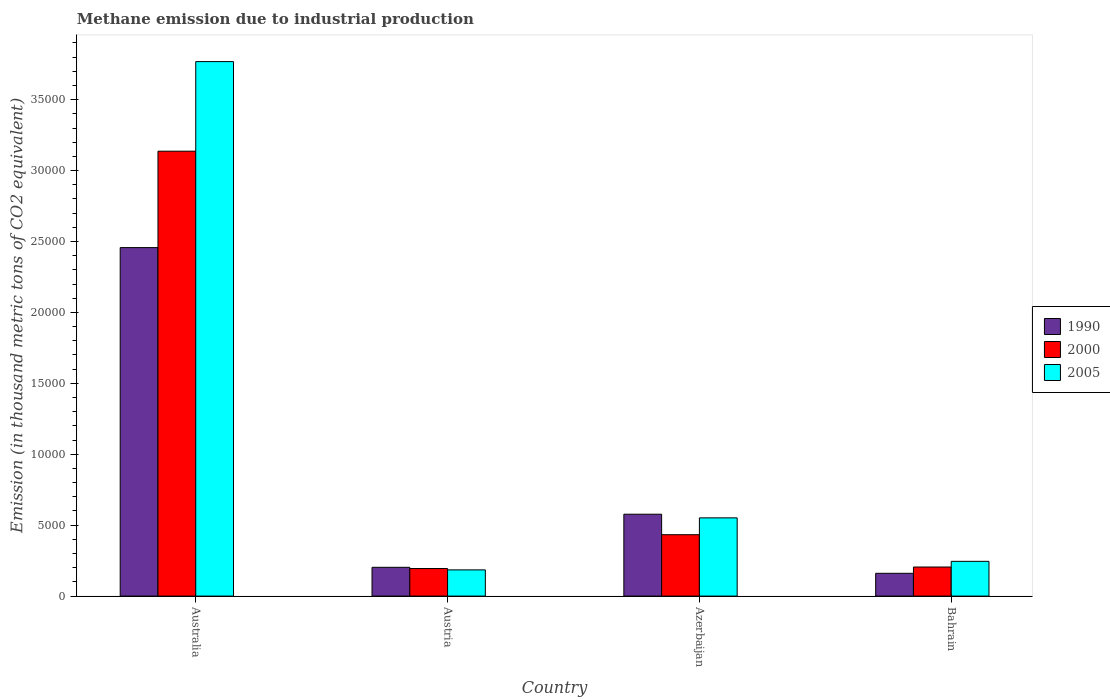How many groups of bars are there?
Your answer should be very brief. 4. How many bars are there on the 2nd tick from the left?
Offer a terse response. 3. How many bars are there on the 3rd tick from the right?
Make the answer very short. 3. What is the amount of methane emitted in 1990 in Austria?
Your response must be concise. 2030.6. Across all countries, what is the maximum amount of methane emitted in 1990?
Offer a very short reply. 2.46e+04. Across all countries, what is the minimum amount of methane emitted in 1990?
Offer a very short reply. 1607.3. What is the total amount of methane emitted in 2005 in the graph?
Your answer should be compact. 4.75e+04. What is the difference between the amount of methane emitted in 2000 in Australia and that in Azerbaijan?
Keep it short and to the point. 2.70e+04. What is the difference between the amount of methane emitted in 2005 in Bahrain and the amount of methane emitted in 2000 in Azerbaijan?
Provide a succinct answer. -1877.2. What is the average amount of methane emitted in 1990 per country?
Ensure brevity in your answer.  8495.27. What is the difference between the amount of methane emitted of/in 2000 and amount of methane emitted of/in 1990 in Australia?
Your answer should be very brief. 6797.8. What is the ratio of the amount of methane emitted in 2005 in Azerbaijan to that in Bahrain?
Your answer should be compact. 2.25. Is the amount of methane emitted in 1990 in Australia less than that in Azerbaijan?
Your response must be concise. No. What is the difference between the highest and the second highest amount of methane emitted in 1990?
Provide a succinct answer. 1.88e+04. What is the difference between the highest and the lowest amount of methane emitted in 2000?
Offer a terse response. 2.94e+04. Is the sum of the amount of methane emitted in 2005 in Austria and Bahrain greater than the maximum amount of methane emitted in 1990 across all countries?
Your response must be concise. No. What does the 2nd bar from the left in Bahrain represents?
Provide a short and direct response. 2000. Are all the bars in the graph horizontal?
Make the answer very short. No. What is the difference between two consecutive major ticks on the Y-axis?
Ensure brevity in your answer.  5000. Does the graph contain grids?
Provide a succinct answer. No. Where does the legend appear in the graph?
Your response must be concise. Center right. How many legend labels are there?
Ensure brevity in your answer.  3. How are the legend labels stacked?
Your response must be concise. Vertical. What is the title of the graph?
Ensure brevity in your answer.  Methane emission due to industrial production. Does "1985" appear as one of the legend labels in the graph?
Your response must be concise. No. What is the label or title of the X-axis?
Offer a terse response. Country. What is the label or title of the Y-axis?
Your response must be concise. Emission (in thousand metric tons of CO2 equivalent). What is the Emission (in thousand metric tons of CO2 equivalent) of 1990 in Australia?
Your answer should be very brief. 2.46e+04. What is the Emission (in thousand metric tons of CO2 equivalent) in 2000 in Australia?
Provide a succinct answer. 3.14e+04. What is the Emission (in thousand metric tons of CO2 equivalent) in 2005 in Australia?
Offer a terse response. 3.77e+04. What is the Emission (in thousand metric tons of CO2 equivalent) of 1990 in Austria?
Offer a terse response. 2030.6. What is the Emission (in thousand metric tons of CO2 equivalent) in 2000 in Austria?
Your response must be concise. 1944.7. What is the Emission (in thousand metric tons of CO2 equivalent) of 2005 in Austria?
Your answer should be compact. 1848.3. What is the Emission (in thousand metric tons of CO2 equivalent) in 1990 in Azerbaijan?
Keep it short and to the point. 5773. What is the Emission (in thousand metric tons of CO2 equivalent) of 2000 in Azerbaijan?
Provide a succinct answer. 4327.8. What is the Emission (in thousand metric tons of CO2 equivalent) in 2005 in Azerbaijan?
Make the answer very short. 5515.2. What is the Emission (in thousand metric tons of CO2 equivalent) in 1990 in Bahrain?
Provide a short and direct response. 1607.3. What is the Emission (in thousand metric tons of CO2 equivalent) of 2000 in Bahrain?
Ensure brevity in your answer.  2050.3. What is the Emission (in thousand metric tons of CO2 equivalent) in 2005 in Bahrain?
Provide a short and direct response. 2450.6. Across all countries, what is the maximum Emission (in thousand metric tons of CO2 equivalent) in 1990?
Your answer should be compact. 2.46e+04. Across all countries, what is the maximum Emission (in thousand metric tons of CO2 equivalent) in 2000?
Make the answer very short. 3.14e+04. Across all countries, what is the maximum Emission (in thousand metric tons of CO2 equivalent) in 2005?
Give a very brief answer. 3.77e+04. Across all countries, what is the minimum Emission (in thousand metric tons of CO2 equivalent) of 1990?
Offer a terse response. 1607.3. Across all countries, what is the minimum Emission (in thousand metric tons of CO2 equivalent) of 2000?
Ensure brevity in your answer.  1944.7. Across all countries, what is the minimum Emission (in thousand metric tons of CO2 equivalent) of 2005?
Offer a terse response. 1848.3. What is the total Emission (in thousand metric tons of CO2 equivalent) in 1990 in the graph?
Your answer should be compact. 3.40e+04. What is the total Emission (in thousand metric tons of CO2 equivalent) in 2000 in the graph?
Provide a short and direct response. 3.97e+04. What is the total Emission (in thousand metric tons of CO2 equivalent) of 2005 in the graph?
Ensure brevity in your answer.  4.75e+04. What is the difference between the Emission (in thousand metric tons of CO2 equivalent) in 1990 in Australia and that in Austria?
Ensure brevity in your answer.  2.25e+04. What is the difference between the Emission (in thousand metric tons of CO2 equivalent) of 2000 in Australia and that in Austria?
Your answer should be compact. 2.94e+04. What is the difference between the Emission (in thousand metric tons of CO2 equivalent) of 2005 in Australia and that in Austria?
Give a very brief answer. 3.58e+04. What is the difference between the Emission (in thousand metric tons of CO2 equivalent) in 1990 in Australia and that in Azerbaijan?
Keep it short and to the point. 1.88e+04. What is the difference between the Emission (in thousand metric tons of CO2 equivalent) in 2000 in Australia and that in Azerbaijan?
Give a very brief answer. 2.70e+04. What is the difference between the Emission (in thousand metric tons of CO2 equivalent) of 2005 in Australia and that in Azerbaijan?
Give a very brief answer. 3.22e+04. What is the difference between the Emission (in thousand metric tons of CO2 equivalent) in 1990 in Australia and that in Bahrain?
Provide a short and direct response. 2.30e+04. What is the difference between the Emission (in thousand metric tons of CO2 equivalent) of 2000 in Australia and that in Bahrain?
Your answer should be compact. 2.93e+04. What is the difference between the Emission (in thousand metric tons of CO2 equivalent) of 2005 in Australia and that in Bahrain?
Make the answer very short. 3.52e+04. What is the difference between the Emission (in thousand metric tons of CO2 equivalent) of 1990 in Austria and that in Azerbaijan?
Your answer should be compact. -3742.4. What is the difference between the Emission (in thousand metric tons of CO2 equivalent) in 2000 in Austria and that in Azerbaijan?
Provide a short and direct response. -2383.1. What is the difference between the Emission (in thousand metric tons of CO2 equivalent) of 2005 in Austria and that in Azerbaijan?
Your answer should be compact. -3666.9. What is the difference between the Emission (in thousand metric tons of CO2 equivalent) in 1990 in Austria and that in Bahrain?
Offer a very short reply. 423.3. What is the difference between the Emission (in thousand metric tons of CO2 equivalent) of 2000 in Austria and that in Bahrain?
Make the answer very short. -105.6. What is the difference between the Emission (in thousand metric tons of CO2 equivalent) in 2005 in Austria and that in Bahrain?
Ensure brevity in your answer.  -602.3. What is the difference between the Emission (in thousand metric tons of CO2 equivalent) of 1990 in Azerbaijan and that in Bahrain?
Your answer should be very brief. 4165.7. What is the difference between the Emission (in thousand metric tons of CO2 equivalent) in 2000 in Azerbaijan and that in Bahrain?
Provide a short and direct response. 2277.5. What is the difference between the Emission (in thousand metric tons of CO2 equivalent) of 2005 in Azerbaijan and that in Bahrain?
Make the answer very short. 3064.6. What is the difference between the Emission (in thousand metric tons of CO2 equivalent) of 1990 in Australia and the Emission (in thousand metric tons of CO2 equivalent) of 2000 in Austria?
Offer a terse response. 2.26e+04. What is the difference between the Emission (in thousand metric tons of CO2 equivalent) of 1990 in Australia and the Emission (in thousand metric tons of CO2 equivalent) of 2005 in Austria?
Provide a succinct answer. 2.27e+04. What is the difference between the Emission (in thousand metric tons of CO2 equivalent) of 2000 in Australia and the Emission (in thousand metric tons of CO2 equivalent) of 2005 in Austria?
Your answer should be very brief. 2.95e+04. What is the difference between the Emission (in thousand metric tons of CO2 equivalent) of 1990 in Australia and the Emission (in thousand metric tons of CO2 equivalent) of 2000 in Azerbaijan?
Your answer should be compact. 2.02e+04. What is the difference between the Emission (in thousand metric tons of CO2 equivalent) in 1990 in Australia and the Emission (in thousand metric tons of CO2 equivalent) in 2005 in Azerbaijan?
Your answer should be very brief. 1.91e+04. What is the difference between the Emission (in thousand metric tons of CO2 equivalent) in 2000 in Australia and the Emission (in thousand metric tons of CO2 equivalent) in 2005 in Azerbaijan?
Make the answer very short. 2.59e+04. What is the difference between the Emission (in thousand metric tons of CO2 equivalent) of 1990 in Australia and the Emission (in thousand metric tons of CO2 equivalent) of 2000 in Bahrain?
Provide a short and direct response. 2.25e+04. What is the difference between the Emission (in thousand metric tons of CO2 equivalent) in 1990 in Australia and the Emission (in thousand metric tons of CO2 equivalent) in 2005 in Bahrain?
Your response must be concise. 2.21e+04. What is the difference between the Emission (in thousand metric tons of CO2 equivalent) of 2000 in Australia and the Emission (in thousand metric tons of CO2 equivalent) of 2005 in Bahrain?
Make the answer very short. 2.89e+04. What is the difference between the Emission (in thousand metric tons of CO2 equivalent) of 1990 in Austria and the Emission (in thousand metric tons of CO2 equivalent) of 2000 in Azerbaijan?
Keep it short and to the point. -2297.2. What is the difference between the Emission (in thousand metric tons of CO2 equivalent) of 1990 in Austria and the Emission (in thousand metric tons of CO2 equivalent) of 2005 in Azerbaijan?
Ensure brevity in your answer.  -3484.6. What is the difference between the Emission (in thousand metric tons of CO2 equivalent) in 2000 in Austria and the Emission (in thousand metric tons of CO2 equivalent) in 2005 in Azerbaijan?
Your answer should be compact. -3570.5. What is the difference between the Emission (in thousand metric tons of CO2 equivalent) in 1990 in Austria and the Emission (in thousand metric tons of CO2 equivalent) in 2000 in Bahrain?
Your answer should be compact. -19.7. What is the difference between the Emission (in thousand metric tons of CO2 equivalent) of 1990 in Austria and the Emission (in thousand metric tons of CO2 equivalent) of 2005 in Bahrain?
Keep it short and to the point. -420. What is the difference between the Emission (in thousand metric tons of CO2 equivalent) in 2000 in Austria and the Emission (in thousand metric tons of CO2 equivalent) in 2005 in Bahrain?
Offer a very short reply. -505.9. What is the difference between the Emission (in thousand metric tons of CO2 equivalent) in 1990 in Azerbaijan and the Emission (in thousand metric tons of CO2 equivalent) in 2000 in Bahrain?
Offer a very short reply. 3722.7. What is the difference between the Emission (in thousand metric tons of CO2 equivalent) of 1990 in Azerbaijan and the Emission (in thousand metric tons of CO2 equivalent) of 2005 in Bahrain?
Provide a short and direct response. 3322.4. What is the difference between the Emission (in thousand metric tons of CO2 equivalent) in 2000 in Azerbaijan and the Emission (in thousand metric tons of CO2 equivalent) in 2005 in Bahrain?
Offer a terse response. 1877.2. What is the average Emission (in thousand metric tons of CO2 equivalent) in 1990 per country?
Ensure brevity in your answer.  8495.27. What is the average Emission (in thousand metric tons of CO2 equivalent) in 2000 per country?
Provide a succinct answer. 9922.7. What is the average Emission (in thousand metric tons of CO2 equivalent) in 2005 per country?
Offer a very short reply. 1.19e+04. What is the difference between the Emission (in thousand metric tons of CO2 equivalent) of 1990 and Emission (in thousand metric tons of CO2 equivalent) of 2000 in Australia?
Provide a short and direct response. -6797.8. What is the difference between the Emission (in thousand metric tons of CO2 equivalent) of 1990 and Emission (in thousand metric tons of CO2 equivalent) of 2005 in Australia?
Offer a terse response. -1.31e+04. What is the difference between the Emission (in thousand metric tons of CO2 equivalent) of 2000 and Emission (in thousand metric tons of CO2 equivalent) of 2005 in Australia?
Provide a short and direct response. -6316.4. What is the difference between the Emission (in thousand metric tons of CO2 equivalent) in 1990 and Emission (in thousand metric tons of CO2 equivalent) in 2000 in Austria?
Your answer should be compact. 85.9. What is the difference between the Emission (in thousand metric tons of CO2 equivalent) of 1990 and Emission (in thousand metric tons of CO2 equivalent) of 2005 in Austria?
Keep it short and to the point. 182.3. What is the difference between the Emission (in thousand metric tons of CO2 equivalent) of 2000 and Emission (in thousand metric tons of CO2 equivalent) of 2005 in Austria?
Provide a short and direct response. 96.4. What is the difference between the Emission (in thousand metric tons of CO2 equivalent) of 1990 and Emission (in thousand metric tons of CO2 equivalent) of 2000 in Azerbaijan?
Ensure brevity in your answer.  1445.2. What is the difference between the Emission (in thousand metric tons of CO2 equivalent) in 1990 and Emission (in thousand metric tons of CO2 equivalent) in 2005 in Azerbaijan?
Provide a short and direct response. 257.8. What is the difference between the Emission (in thousand metric tons of CO2 equivalent) of 2000 and Emission (in thousand metric tons of CO2 equivalent) of 2005 in Azerbaijan?
Ensure brevity in your answer.  -1187.4. What is the difference between the Emission (in thousand metric tons of CO2 equivalent) of 1990 and Emission (in thousand metric tons of CO2 equivalent) of 2000 in Bahrain?
Your response must be concise. -443. What is the difference between the Emission (in thousand metric tons of CO2 equivalent) of 1990 and Emission (in thousand metric tons of CO2 equivalent) of 2005 in Bahrain?
Offer a terse response. -843.3. What is the difference between the Emission (in thousand metric tons of CO2 equivalent) of 2000 and Emission (in thousand metric tons of CO2 equivalent) of 2005 in Bahrain?
Your answer should be compact. -400.3. What is the ratio of the Emission (in thousand metric tons of CO2 equivalent) of 2000 in Australia to that in Austria?
Make the answer very short. 16.13. What is the ratio of the Emission (in thousand metric tons of CO2 equivalent) in 2005 in Australia to that in Austria?
Offer a very short reply. 20.39. What is the ratio of the Emission (in thousand metric tons of CO2 equivalent) in 1990 in Australia to that in Azerbaijan?
Keep it short and to the point. 4.26. What is the ratio of the Emission (in thousand metric tons of CO2 equivalent) of 2000 in Australia to that in Azerbaijan?
Provide a short and direct response. 7.25. What is the ratio of the Emission (in thousand metric tons of CO2 equivalent) in 2005 in Australia to that in Azerbaijan?
Make the answer very short. 6.83. What is the ratio of the Emission (in thousand metric tons of CO2 equivalent) in 1990 in Australia to that in Bahrain?
Provide a short and direct response. 15.29. What is the ratio of the Emission (in thousand metric tons of CO2 equivalent) of 2000 in Australia to that in Bahrain?
Provide a short and direct response. 15.3. What is the ratio of the Emission (in thousand metric tons of CO2 equivalent) in 2005 in Australia to that in Bahrain?
Your answer should be compact. 15.38. What is the ratio of the Emission (in thousand metric tons of CO2 equivalent) of 1990 in Austria to that in Azerbaijan?
Your response must be concise. 0.35. What is the ratio of the Emission (in thousand metric tons of CO2 equivalent) in 2000 in Austria to that in Azerbaijan?
Keep it short and to the point. 0.45. What is the ratio of the Emission (in thousand metric tons of CO2 equivalent) in 2005 in Austria to that in Azerbaijan?
Give a very brief answer. 0.34. What is the ratio of the Emission (in thousand metric tons of CO2 equivalent) of 1990 in Austria to that in Bahrain?
Make the answer very short. 1.26. What is the ratio of the Emission (in thousand metric tons of CO2 equivalent) in 2000 in Austria to that in Bahrain?
Offer a terse response. 0.95. What is the ratio of the Emission (in thousand metric tons of CO2 equivalent) of 2005 in Austria to that in Bahrain?
Offer a terse response. 0.75. What is the ratio of the Emission (in thousand metric tons of CO2 equivalent) of 1990 in Azerbaijan to that in Bahrain?
Your answer should be compact. 3.59. What is the ratio of the Emission (in thousand metric tons of CO2 equivalent) in 2000 in Azerbaijan to that in Bahrain?
Your answer should be compact. 2.11. What is the ratio of the Emission (in thousand metric tons of CO2 equivalent) in 2005 in Azerbaijan to that in Bahrain?
Make the answer very short. 2.25. What is the difference between the highest and the second highest Emission (in thousand metric tons of CO2 equivalent) of 1990?
Ensure brevity in your answer.  1.88e+04. What is the difference between the highest and the second highest Emission (in thousand metric tons of CO2 equivalent) of 2000?
Offer a terse response. 2.70e+04. What is the difference between the highest and the second highest Emission (in thousand metric tons of CO2 equivalent) in 2005?
Offer a terse response. 3.22e+04. What is the difference between the highest and the lowest Emission (in thousand metric tons of CO2 equivalent) in 1990?
Provide a short and direct response. 2.30e+04. What is the difference between the highest and the lowest Emission (in thousand metric tons of CO2 equivalent) in 2000?
Your answer should be compact. 2.94e+04. What is the difference between the highest and the lowest Emission (in thousand metric tons of CO2 equivalent) in 2005?
Your answer should be compact. 3.58e+04. 